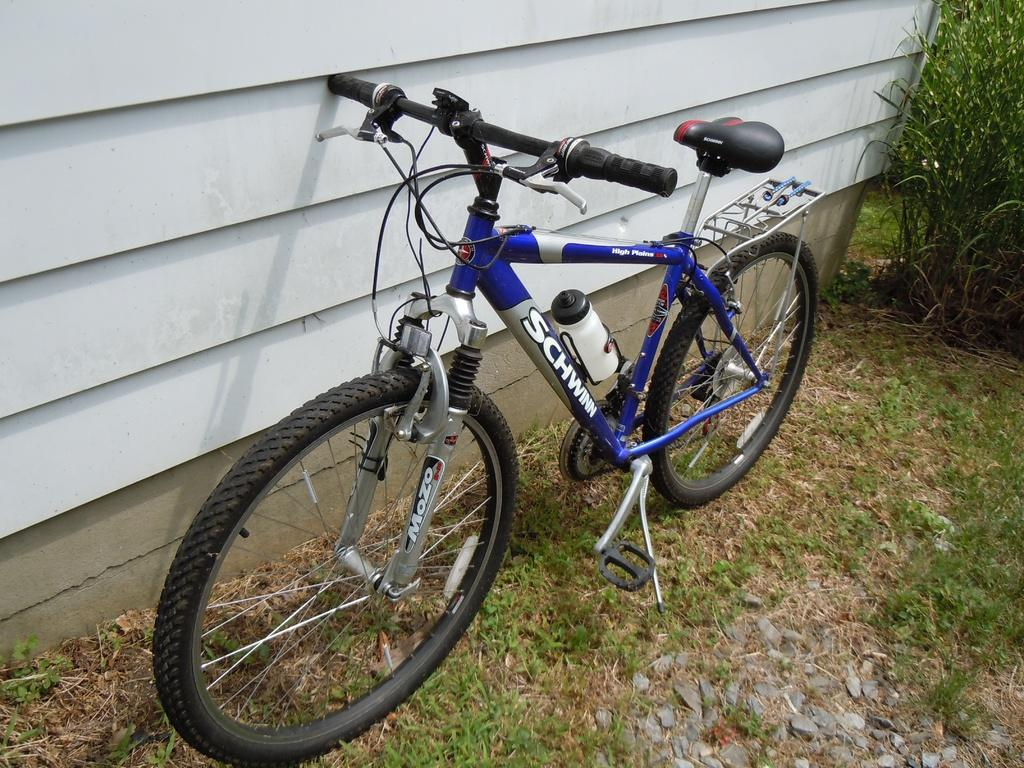What is the main object in the image? There is a cycle in the image. Where is the cycle located in relation to other objects? The cycle is beside a wall. What can be seen in the top right corner of the image? There are plants in the top right corner of the image. What type of yarn is being used to decorate the cycle in the image? There is no yarn present in the image, and the cycle is not being decorated with any yarn. 